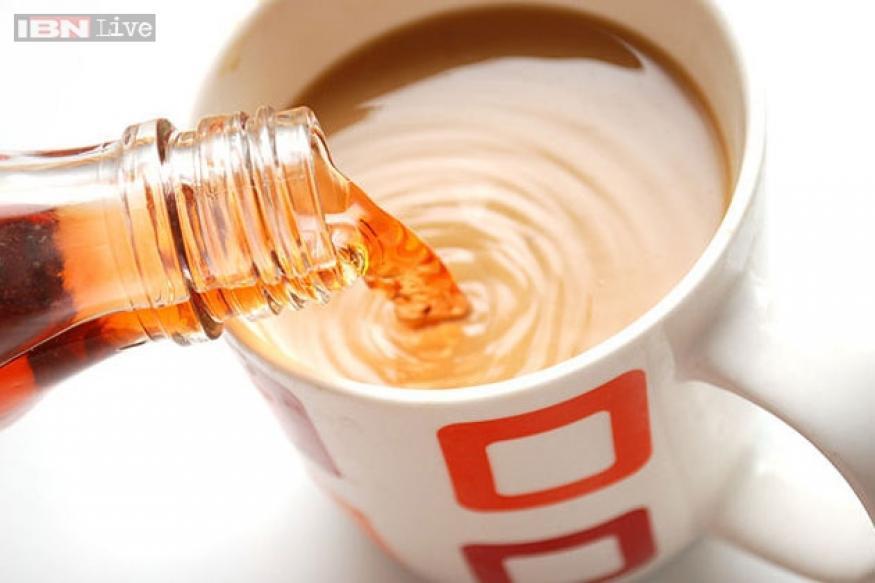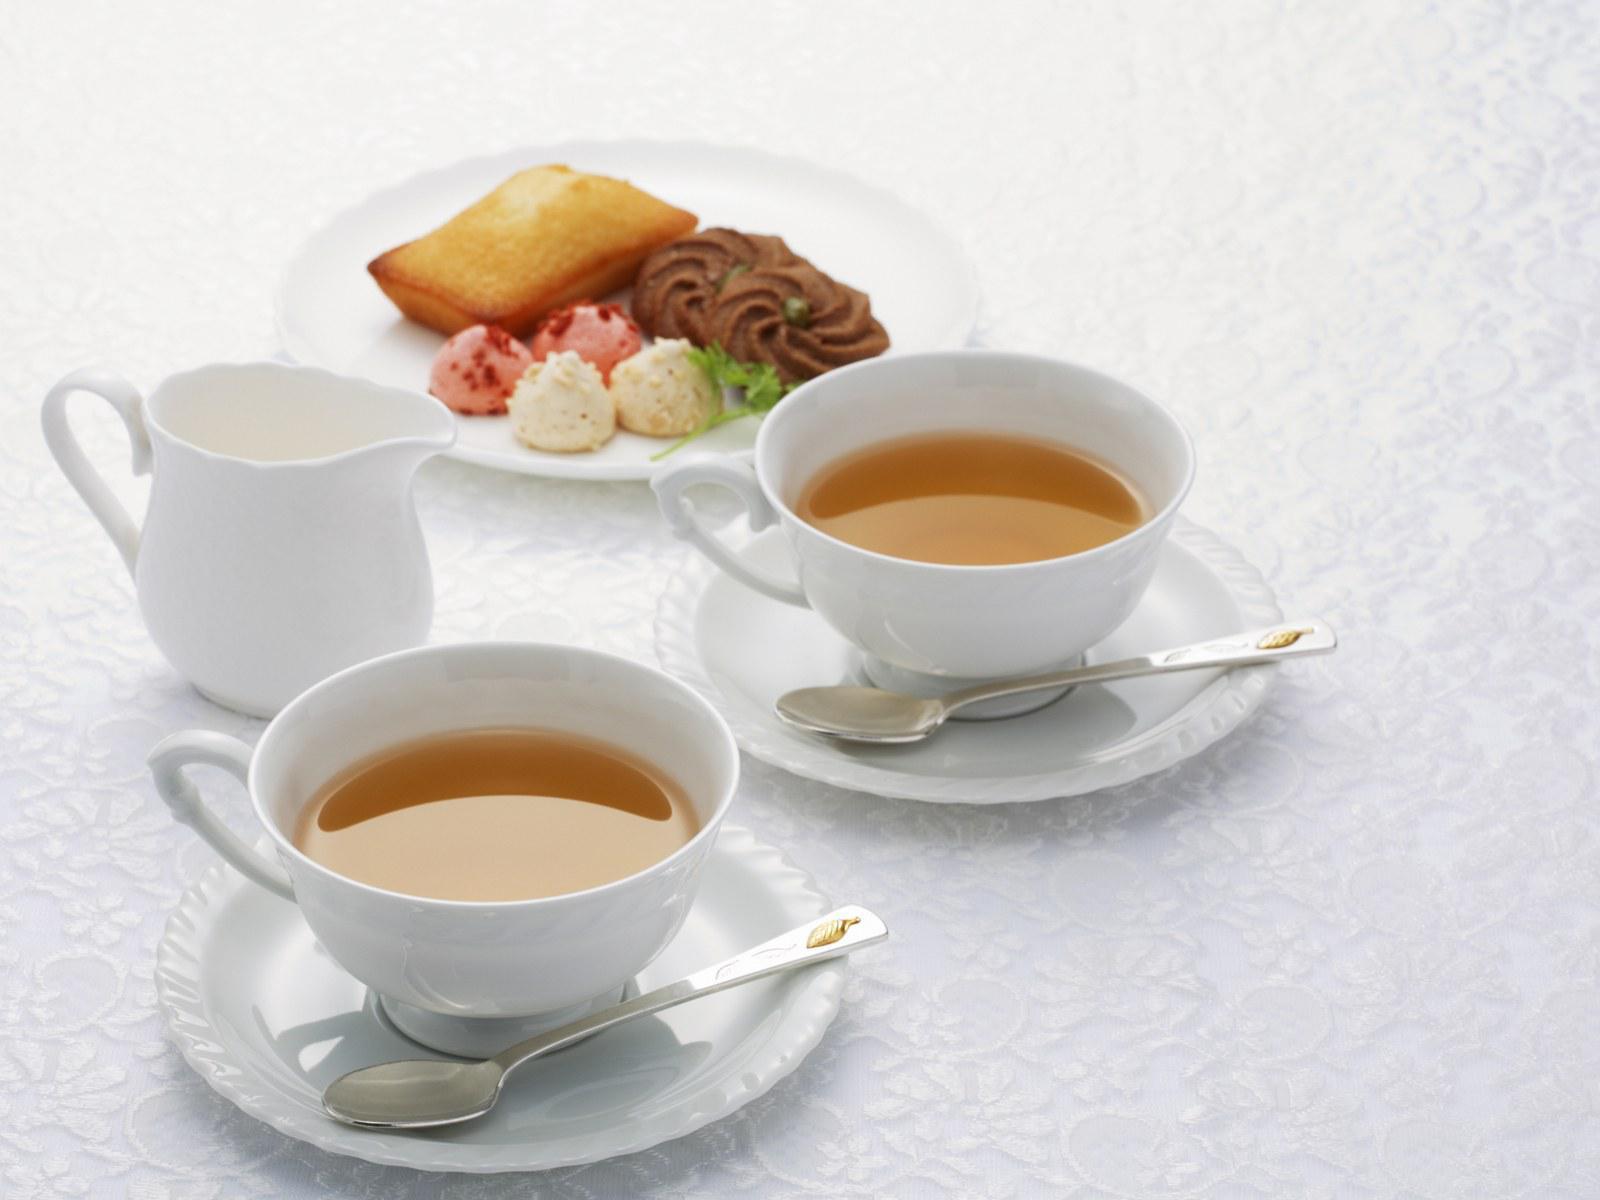The first image is the image on the left, the second image is the image on the right. Evaluate the accuracy of this statement regarding the images: "In one image, a liquid is being poured into a white cup from a white tea kettle". Is it true? Answer yes or no. No. The first image is the image on the left, the second image is the image on the right. For the images shown, is this caption "A white teapot is pouring tea into a cup in one of the images." true? Answer yes or no. No. 